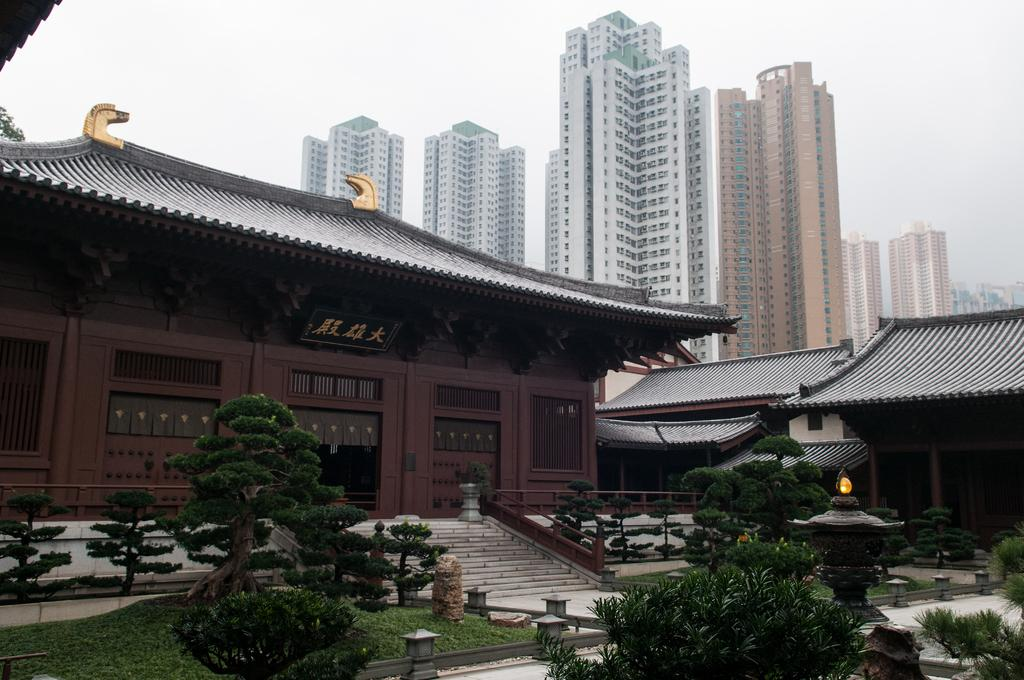What type of architecture is featured in the image? There are Chinese ancient architectures in the image. What object can be seen in the image that might be used for displaying information or advertisements? There is a board in the image. What type of vegetation is present in the image? There are plants and grass in the image. What type of lighting is present in the image? There are lights in the image. What architectural feature is present in the image that allows for easy navigation between different levels? There are steps in the image. What safety feature is present in the image to prevent people from falling? There are railings in the image. What can be seen in the background of the image? There are buildings and sky visible in the background of the image. What type of fowl can be seen flying in the image? There is no fowl present in the image. How many parcels are being delivered in the image? There is no mention of parcels or delivery in the image. 